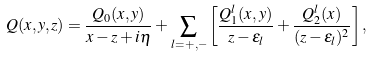Convert formula to latex. <formula><loc_0><loc_0><loc_500><loc_500>Q ( x , y , z ) = \frac { Q _ { 0 } ( x , y ) } { x - z + i \eta } + \sum _ { l = + , - } \left [ \frac { Q ^ { l } _ { 1 } ( x , y ) } { z - \epsilon _ { l } } + \frac { Q ^ { l } _ { 2 } ( x ) } { ( z - \epsilon _ { l } ) ^ { 2 } } \right ] ,</formula> 